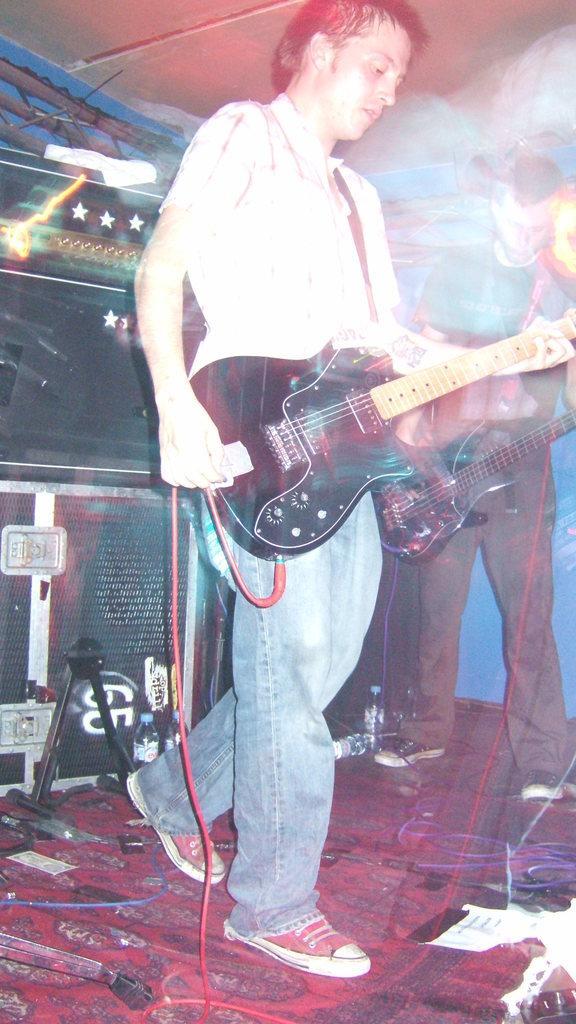How would you summarize this image in a sentence or two? One person is wearing a guitar and wearing shoes behind him two water bottles are there ,other person is also there he is wearing a guitar too. They are playing them ,under them so many wires are there. 